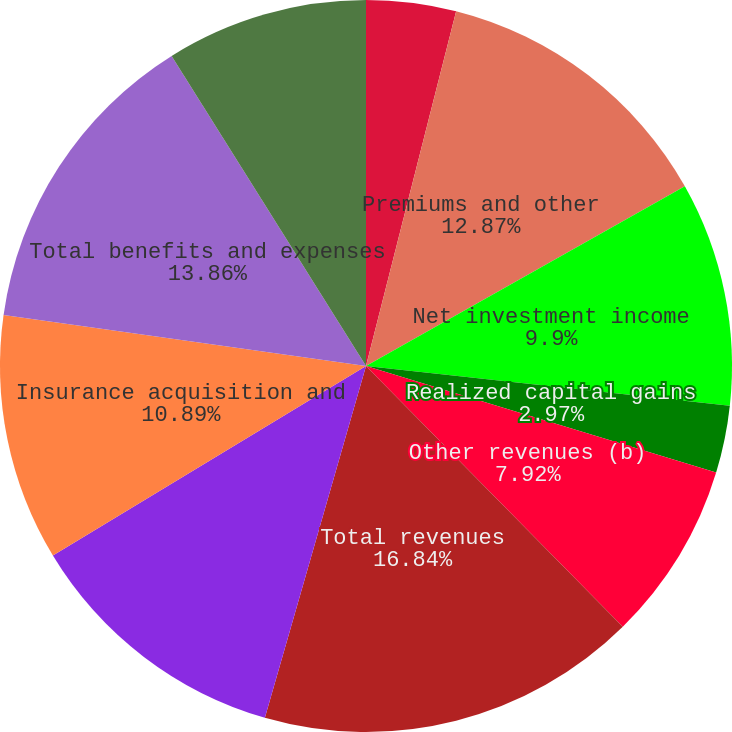Convert chart. <chart><loc_0><loc_0><loc_500><loc_500><pie_chart><fcel>Years Ended December 31 (in<fcel>Premiums and other<fcel>Net investment income<fcel>Realized capital gains<fcel>Other revenues (b)<fcel>Total revenues<fcel>Incurred policy losses and<fcel>Insurance acquisition and<fcel>Total benefits and expenses<fcel>Income before income taxes<nl><fcel>3.96%<fcel>12.87%<fcel>9.9%<fcel>2.97%<fcel>7.92%<fcel>16.83%<fcel>11.88%<fcel>10.89%<fcel>13.86%<fcel>8.91%<nl></chart> 